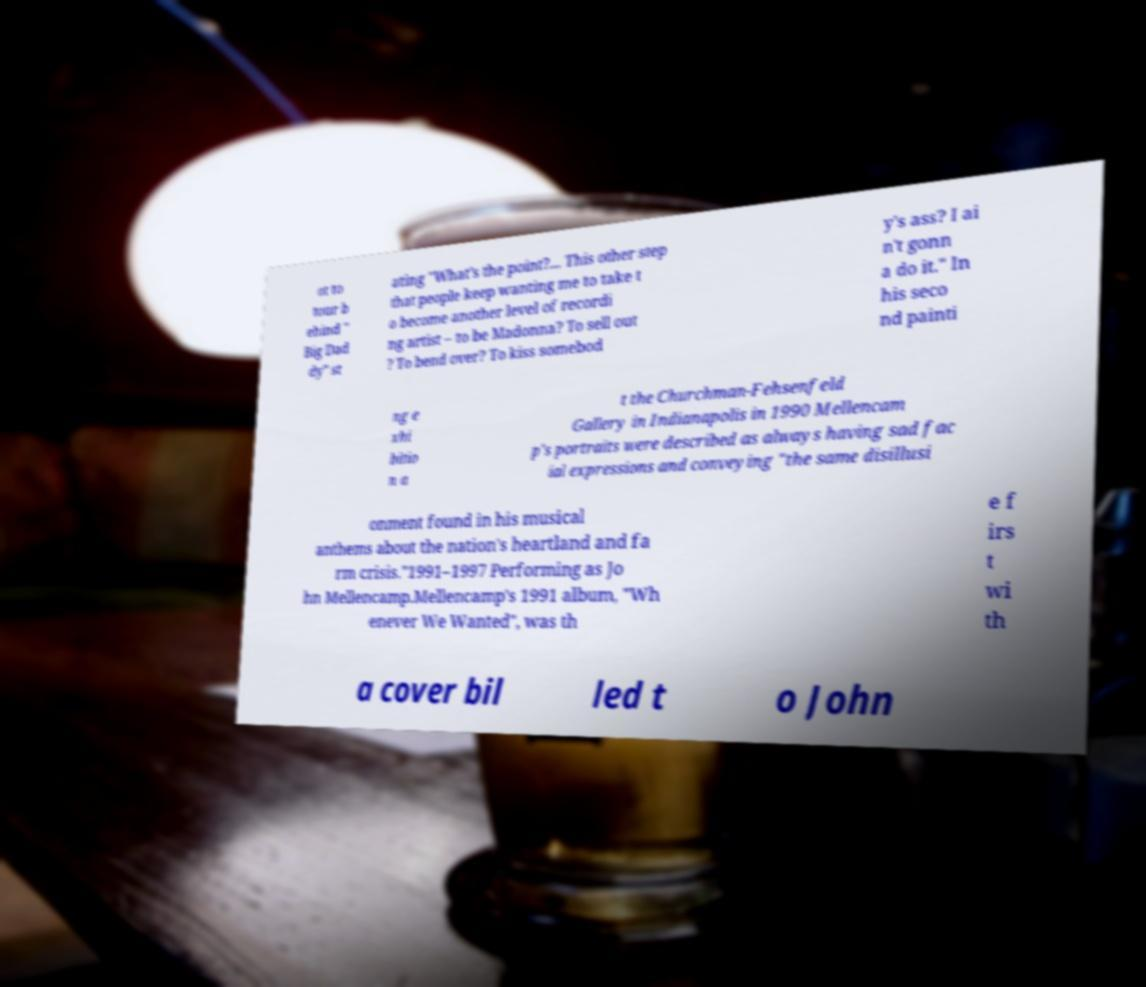Could you extract and type out the text from this image? ot to tour b ehind " Big Dad dy" st ating "What's the point?... This other step that people keep wanting me to take t o become another level of recordi ng artist – to be Madonna? To sell out ? To bend over? To kiss somebod y's ass? I ai n't gonn a do it." In his seco nd painti ng e xhi bitio n a t the Churchman-Fehsenfeld Gallery in Indianapolis in 1990 Mellencam p's portraits were described as always having sad fac ial expressions and conveying "the same disillusi onment found in his musical anthems about the nation's heartland and fa rm crisis."1991–1997 Performing as Jo hn Mellencamp.Mellencamp's 1991 album, "Wh enever We Wanted", was th e f irs t wi th a cover bil led t o John 